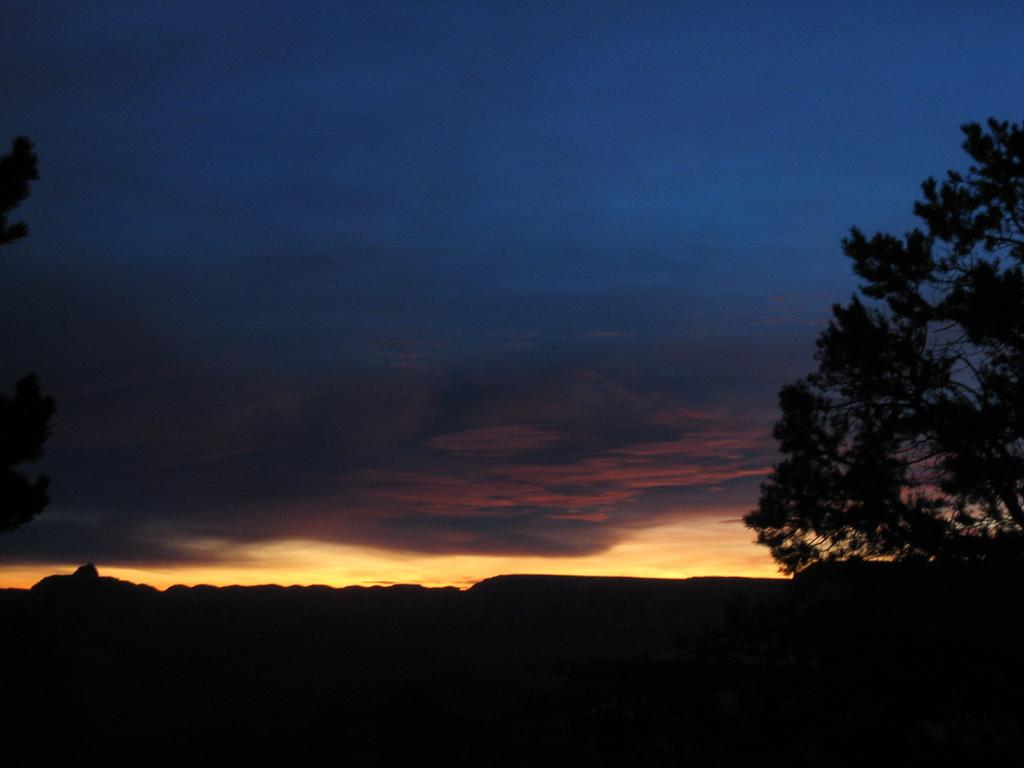What type of vegetation can be seen on both sides of the image? There are trees on both the right and left sides of the image. What is the color of the background in the image? The background of the image is dark. What is visible at the top of the image? The sky is visible at the top of the image. What can be observed in the sky? Clouds are present in the sky. What shape is the steel boat in the image? There is no steel boat present in the image. What type of steel is used to construct the boat in the image? There is no boat, steel, or any construction material mentioned in the image. 